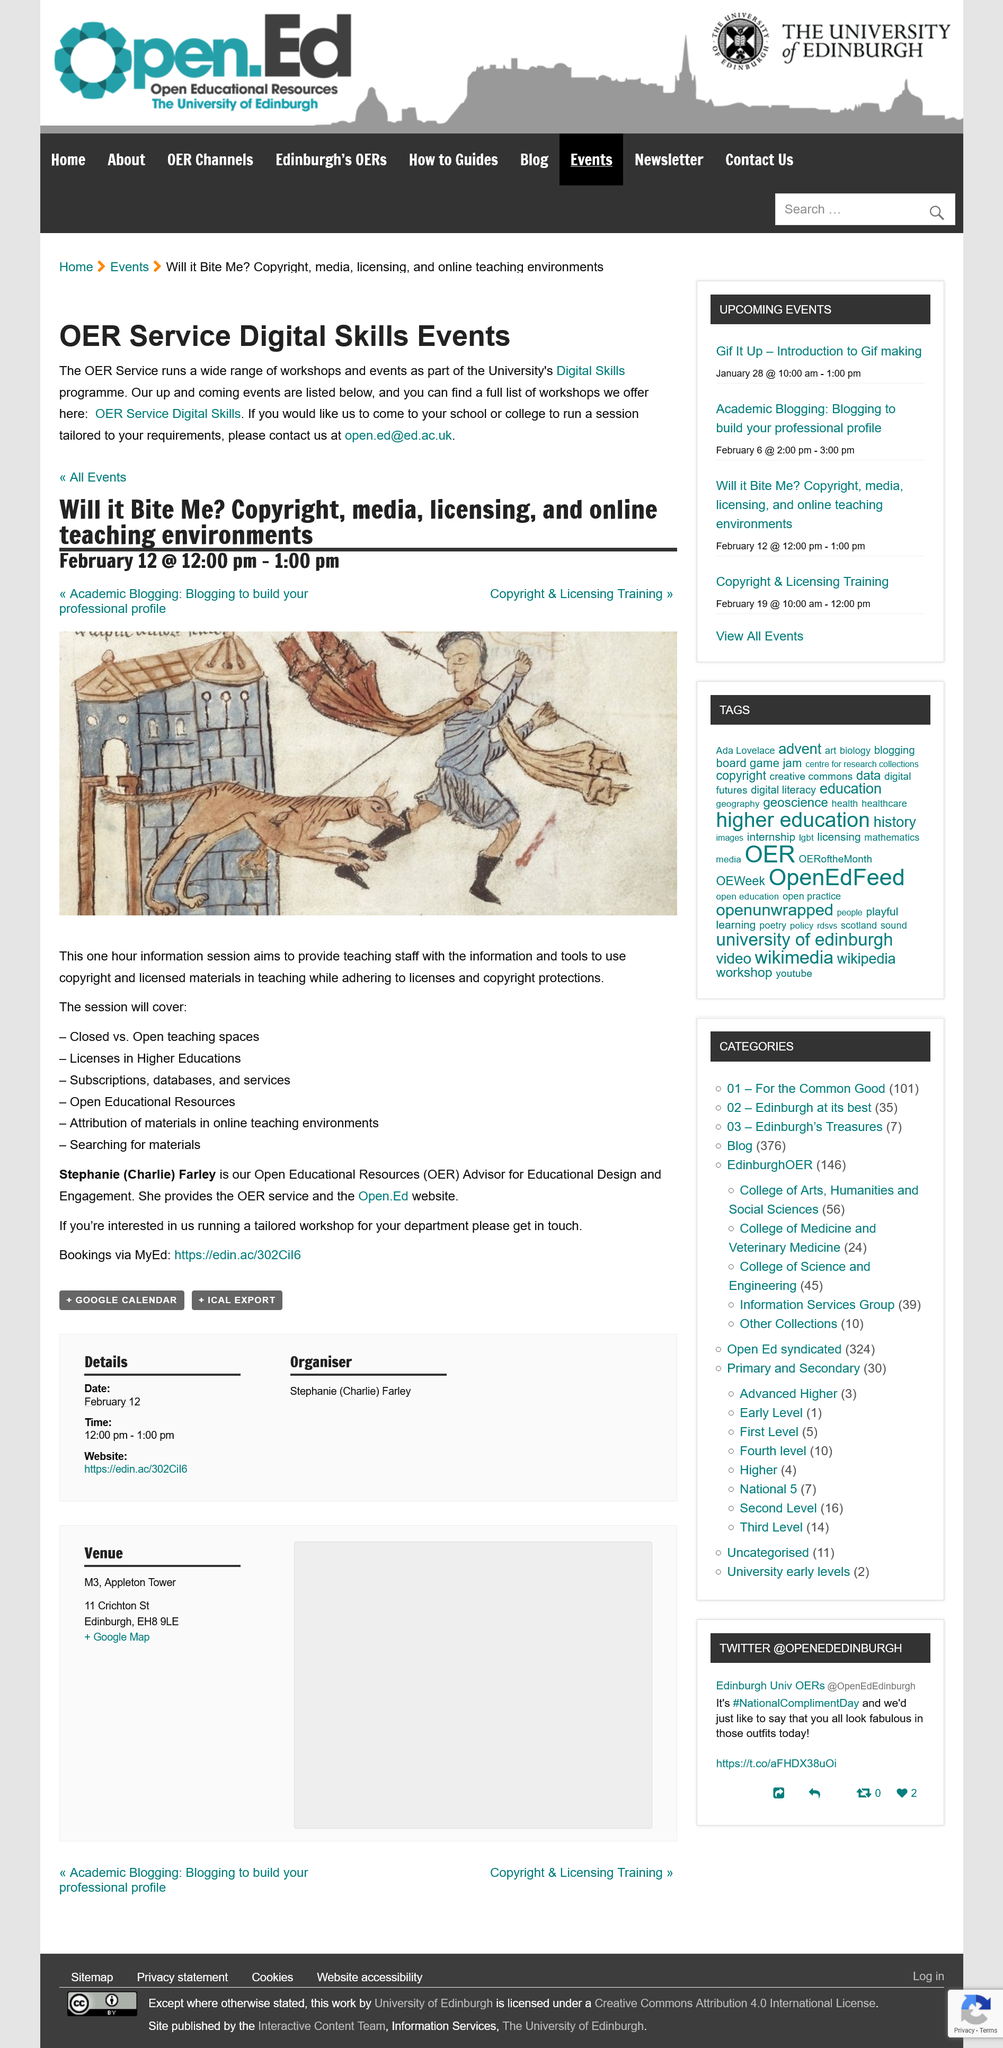Highlight a few significant elements in this photo. The session shall commence at 12:00 pm on February 12th and shall conclude at 1:00 pm on the same day. During the one hour information session, the aim is to impart to teaching staff the necessary information and tools to effectively incorporate copyright and licensed materials into their teaching while maintaining compliance with licenses and copyright protection. Stephanie (Charlie) Farley serves as the OER Advisor for Educational Design and Engagement, playing a vital role in our organization. 